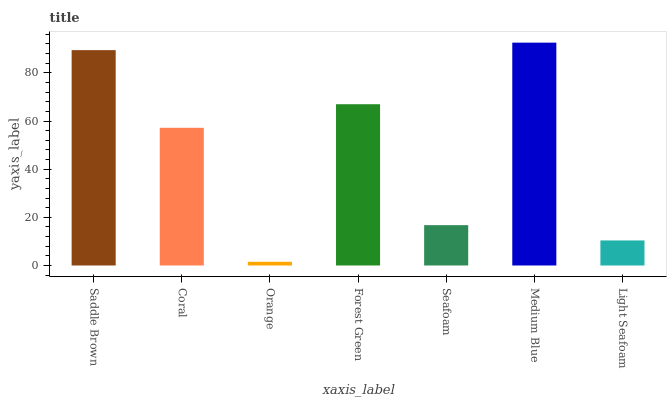Is Orange the minimum?
Answer yes or no. Yes. Is Medium Blue the maximum?
Answer yes or no. Yes. Is Coral the minimum?
Answer yes or no. No. Is Coral the maximum?
Answer yes or no. No. Is Saddle Brown greater than Coral?
Answer yes or no. Yes. Is Coral less than Saddle Brown?
Answer yes or no. Yes. Is Coral greater than Saddle Brown?
Answer yes or no. No. Is Saddle Brown less than Coral?
Answer yes or no. No. Is Coral the high median?
Answer yes or no. Yes. Is Coral the low median?
Answer yes or no. Yes. Is Orange the high median?
Answer yes or no. No. Is Orange the low median?
Answer yes or no. No. 